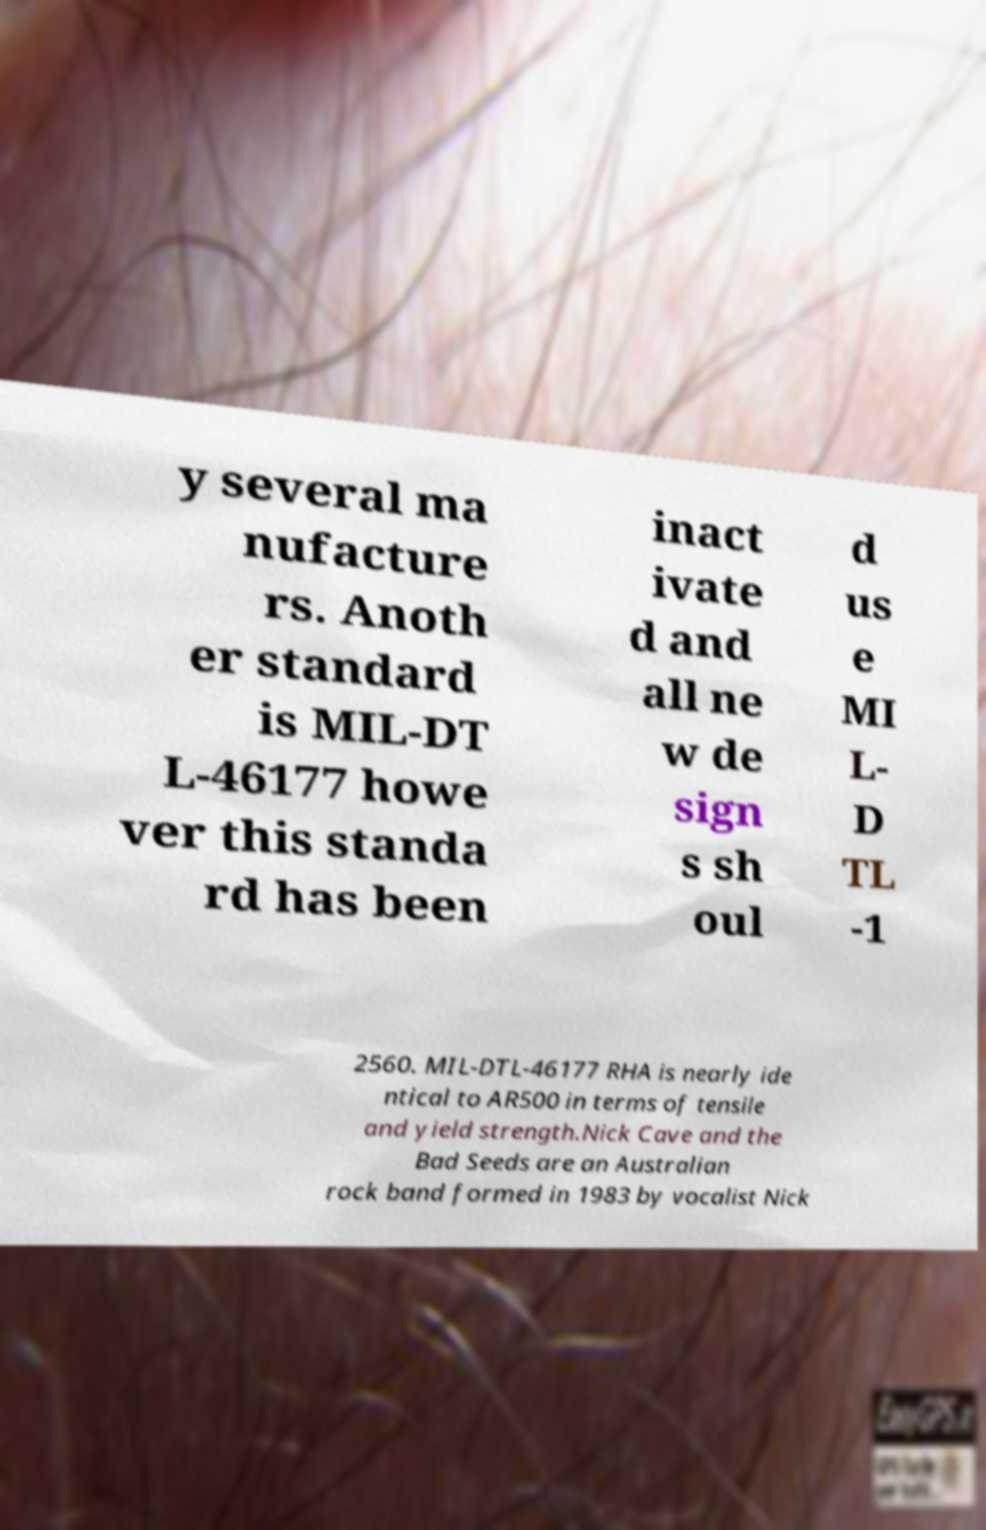Please read and relay the text visible in this image. What does it say? y several ma nufacture rs. Anoth er standard is MIL-DT L-46177 howe ver this standa rd has been inact ivate d and all ne w de sign s sh oul d us e MI L- D TL -1 2560. MIL-DTL-46177 RHA is nearly ide ntical to AR500 in terms of tensile and yield strength.Nick Cave and the Bad Seeds are an Australian rock band formed in 1983 by vocalist Nick 